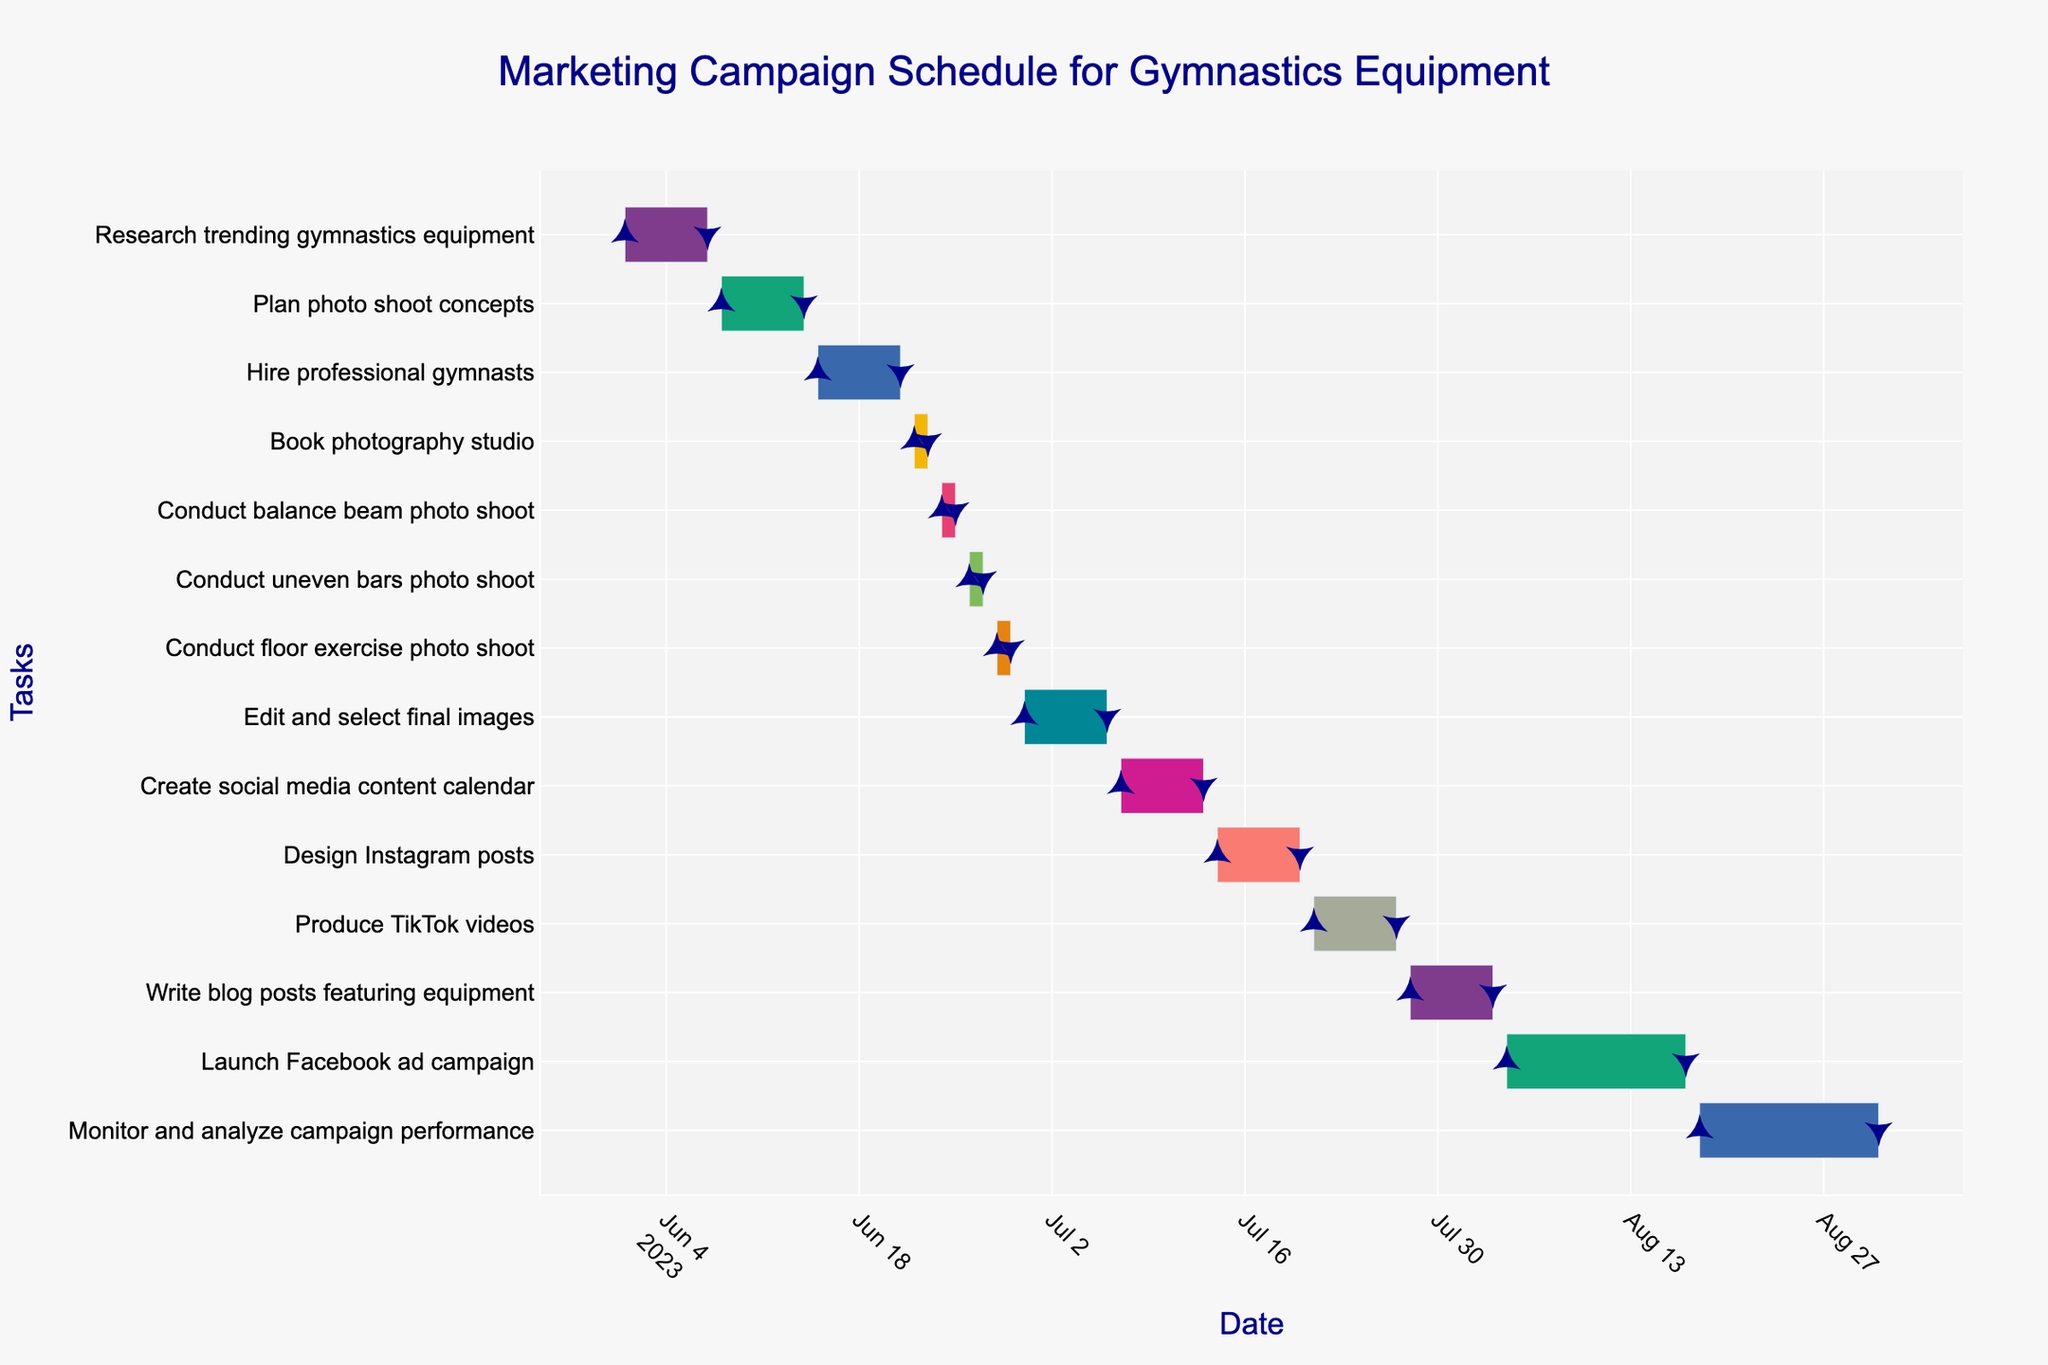What is the title of the Gantt chart? The title of a Gantt chart is usually displayed prominently at the top of the figure.
Answer: Marketing Campaign Schedule for Gymnastics Equipment What task starts on June 15 and ends on June 21? The Gantt chart shows tasks and their corresponding start and end dates. Locate the bar that starts on June 15 and ends on June 21.
Answer: Hire professional gymnasts How long does the "Edit and select final images" task take? Find the "Edit and select final images" task and calculate the duration by subtracting the start date from the end date.
Answer: 7 days Which tasks involve conducting photo shoots? Identify the bars labeled with photo shoots in their task names, such as "Conduct balance beam photo shoot," "Conduct uneven bars photo shoot," and "Conduct floor exercise photo shoot."
Answer: Conduct balance beam photo shoot, Conduct uneven bars photo shoot, Conduct floor exercise photo shoot How many days are spent on booking the photography studio? Look for the "Book photography studio" task, and calculate the duration by subtracting the start date from the end date.
Answer: 2 days Which task immediately follows the "Plan photo shoot concepts"? Identify the "Plan photo shoot concepts" bar, then look for the next task that starts after this task ends.
Answer: Hire professional gymnasts What is the duration of the "Launch Facebook ad campaign" task? Find the "Launch Facebook ad campaign" task and calculate the duration by subtracting the start date from the end date.
Answer: 14 days Which task has the shortest duration? Compare the durations of all tasks by looking at the lengths of the bars in the Gantt chart.
Answer: Book photography studio How long is the entire campaign, from the first task to the last task? Identify the start date of the first task and the end date of the last task, then calculate the duration by subtracting the start date from the end date.
Answer: 92 days Which task runs concurrently with "Produce TikTok videos"? Identify the "Produce TikTok videos" task, then find any other tasks that have overlapping dates with this task.
Answer: Design Instagram posts, Write blog posts featuring equipment 